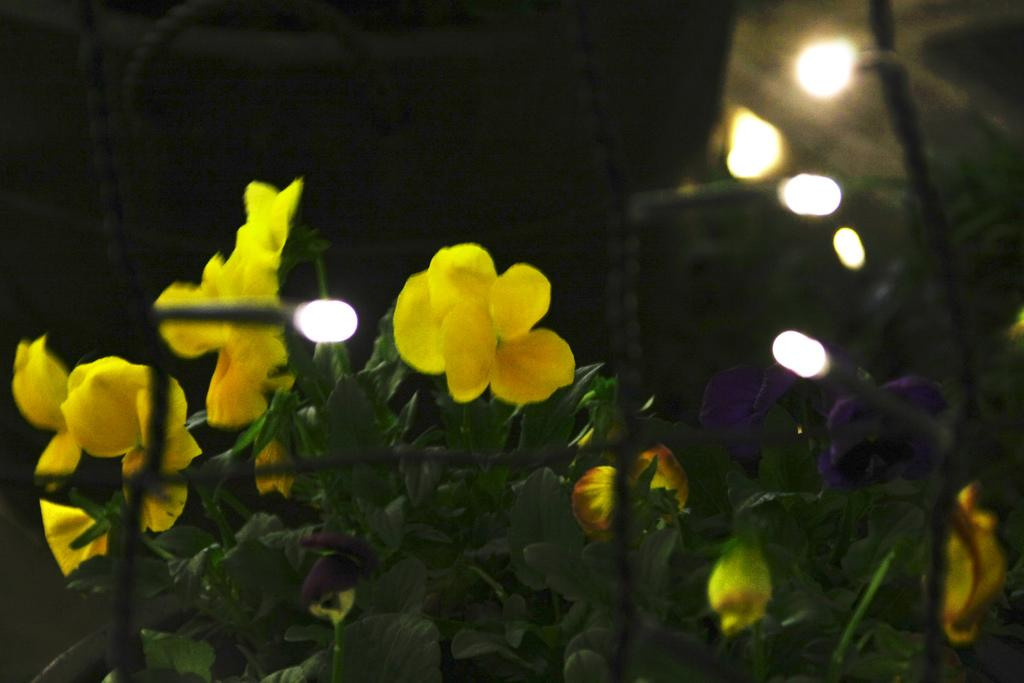What type of plants can be seen in the image? There are plants with flowers in the image. How are the plants arranged or contained in the image? The plants are behind a mesh. What color beads are hanging from the plants in the image? There are no beads present in the image; it only features plants with flowers behind a mesh. 